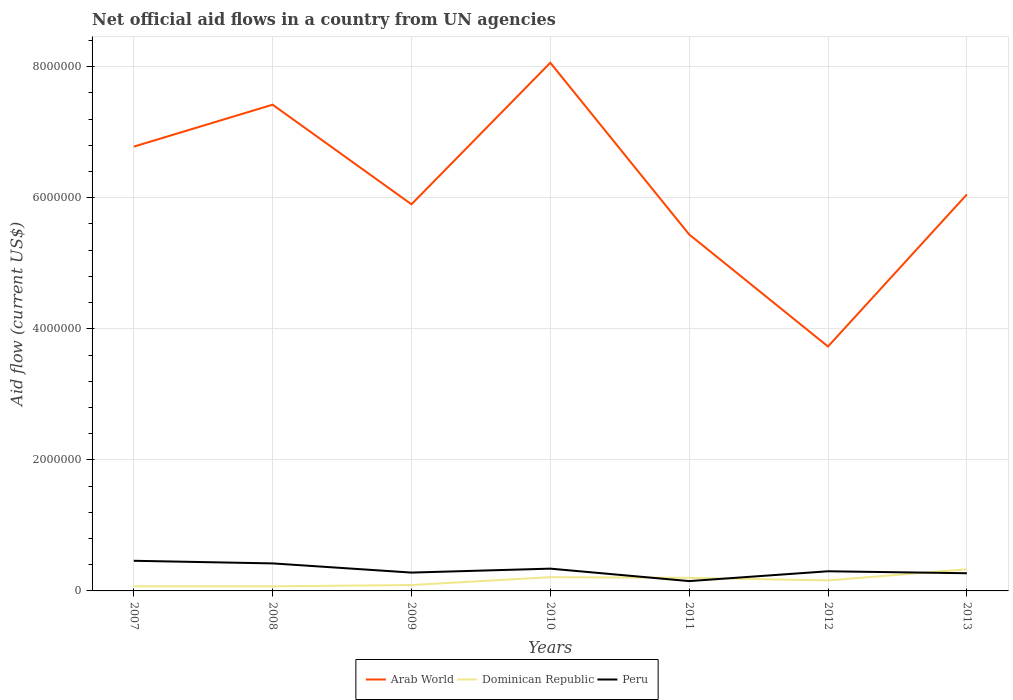Is the number of lines equal to the number of legend labels?
Keep it short and to the point. Yes. Across all years, what is the maximum net official aid flow in Dominican Republic?
Make the answer very short. 7.00e+04. In which year was the net official aid flow in Arab World maximum?
Your answer should be very brief. 2012. What is the total net official aid flow in Arab World in the graph?
Offer a terse response. -2.32e+06. What is the difference between the highest and the second highest net official aid flow in Dominican Republic?
Ensure brevity in your answer.  2.60e+05. Is the net official aid flow in Dominican Republic strictly greater than the net official aid flow in Arab World over the years?
Give a very brief answer. Yes. How many years are there in the graph?
Ensure brevity in your answer.  7. Are the values on the major ticks of Y-axis written in scientific E-notation?
Provide a short and direct response. No. Does the graph contain any zero values?
Give a very brief answer. No. Where does the legend appear in the graph?
Your answer should be compact. Bottom center. How many legend labels are there?
Your response must be concise. 3. What is the title of the graph?
Provide a succinct answer. Net official aid flows in a country from UN agencies. What is the Aid flow (current US$) in Arab World in 2007?
Your answer should be very brief. 6.78e+06. What is the Aid flow (current US$) of Peru in 2007?
Your response must be concise. 4.60e+05. What is the Aid flow (current US$) in Arab World in 2008?
Your answer should be very brief. 7.42e+06. What is the Aid flow (current US$) of Dominican Republic in 2008?
Your answer should be very brief. 7.00e+04. What is the Aid flow (current US$) of Peru in 2008?
Make the answer very short. 4.20e+05. What is the Aid flow (current US$) in Arab World in 2009?
Your answer should be compact. 5.90e+06. What is the Aid flow (current US$) of Peru in 2009?
Your answer should be very brief. 2.80e+05. What is the Aid flow (current US$) in Arab World in 2010?
Your response must be concise. 8.06e+06. What is the Aid flow (current US$) of Dominican Republic in 2010?
Provide a succinct answer. 2.10e+05. What is the Aid flow (current US$) of Peru in 2010?
Provide a succinct answer. 3.40e+05. What is the Aid flow (current US$) of Arab World in 2011?
Keep it short and to the point. 5.44e+06. What is the Aid flow (current US$) of Arab World in 2012?
Provide a short and direct response. 3.73e+06. What is the Aid flow (current US$) in Dominican Republic in 2012?
Your answer should be very brief. 1.60e+05. What is the Aid flow (current US$) of Arab World in 2013?
Your response must be concise. 6.05e+06. What is the Aid flow (current US$) of Dominican Republic in 2013?
Offer a terse response. 3.30e+05. What is the Aid flow (current US$) in Peru in 2013?
Make the answer very short. 2.70e+05. Across all years, what is the maximum Aid flow (current US$) of Arab World?
Offer a terse response. 8.06e+06. Across all years, what is the minimum Aid flow (current US$) of Arab World?
Your answer should be very brief. 3.73e+06. Across all years, what is the minimum Aid flow (current US$) of Dominican Republic?
Offer a terse response. 7.00e+04. What is the total Aid flow (current US$) of Arab World in the graph?
Your answer should be compact. 4.34e+07. What is the total Aid flow (current US$) in Dominican Republic in the graph?
Provide a succinct answer. 1.13e+06. What is the total Aid flow (current US$) of Peru in the graph?
Provide a short and direct response. 2.22e+06. What is the difference between the Aid flow (current US$) of Arab World in 2007 and that in 2008?
Provide a short and direct response. -6.40e+05. What is the difference between the Aid flow (current US$) in Dominican Republic in 2007 and that in 2008?
Your answer should be compact. 0. What is the difference between the Aid flow (current US$) of Peru in 2007 and that in 2008?
Your answer should be compact. 4.00e+04. What is the difference between the Aid flow (current US$) of Arab World in 2007 and that in 2009?
Offer a very short reply. 8.80e+05. What is the difference between the Aid flow (current US$) of Dominican Republic in 2007 and that in 2009?
Offer a terse response. -2.00e+04. What is the difference between the Aid flow (current US$) of Peru in 2007 and that in 2009?
Keep it short and to the point. 1.80e+05. What is the difference between the Aid flow (current US$) of Arab World in 2007 and that in 2010?
Ensure brevity in your answer.  -1.28e+06. What is the difference between the Aid flow (current US$) in Arab World in 2007 and that in 2011?
Make the answer very short. 1.34e+06. What is the difference between the Aid flow (current US$) in Peru in 2007 and that in 2011?
Your response must be concise. 3.10e+05. What is the difference between the Aid flow (current US$) of Arab World in 2007 and that in 2012?
Offer a terse response. 3.05e+06. What is the difference between the Aid flow (current US$) of Dominican Republic in 2007 and that in 2012?
Your answer should be compact. -9.00e+04. What is the difference between the Aid flow (current US$) of Arab World in 2007 and that in 2013?
Provide a succinct answer. 7.30e+05. What is the difference between the Aid flow (current US$) in Dominican Republic in 2007 and that in 2013?
Your response must be concise. -2.60e+05. What is the difference between the Aid flow (current US$) of Peru in 2007 and that in 2013?
Offer a very short reply. 1.90e+05. What is the difference between the Aid flow (current US$) of Arab World in 2008 and that in 2009?
Make the answer very short. 1.52e+06. What is the difference between the Aid flow (current US$) in Peru in 2008 and that in 2009?
Provide a succinct answer. 1.40e+05. What is the difference between the Aid flow (current US$) of Arab World in 2008 and that in 2010?
Provide a succinct answer. -6.40e+05. What is the difference between the Aid flow (current US$) of Dominican Republic in 2008 and that in 2010?
Your answer should be very brief. -1.40e+05. What is the difference between the Aid flow (current US$) of Peru in 2008 and that in 2010?
Provide a short and direct response. 8.00e+04. What is the difference between the Aid flow (current US$) in Arab World in 2008 and that in 2011?
Your response must be concise. 1.98e+06. What is the difference between the Aid flow (current US$) in Dominican Republic in 2008 and that in 2011?
Ensure brevity in your answer.  -1.30e+05. What is the difference between the Aid flow (current US$) in Arab World in 2008 and that in 2012?
Ensure brevity in your answer.  3.69e+06. What is the difference between the Aid flow (current US$) of Arab World in 2008 and that in 2013?
Your response must be concise. 1.37e+06. What is the difference between the Aid flow (current US$) in Peru in 2008 and that in 2013?
Your answer should be compact. 1.50e+05. What is the difference between the Aid flow (current US$) of Arab World in 2009 and that in 2010?
Offer a very short reply. -2.16e+06. What is the difference between the Aid flow (current US$) of Dominican Republic in 2009 and that in 2010?
Keep it short and to the point. -1.20e+05. What is the difference between the Aid flow (current US$) of Arab World in 2009 and that in 2012?
Your answer should be very brief. 2.17e+06. What is the difference between the Aid flow (current US$) in Dominican Republic in 2009 and that in 2013?
Give a very brief answer. -2.40e+05. What is the difference between the Aid flow (current US$) in Arab World in 2010 and that in 2011?
Offer a terse response. 2.62e+06. What is the difference between the Aid flow (current US$) in Arab World in 2010 and that in 2012?
Give a very brief answer. 4.33e+06. What is the difference between the Aid flow (current US$) in Dominican Republic in 2010 and that in 2012?
Your response must be concise. 5.00e+04. What is the difference between the Aid flow (current US$) of Arab World in 2010 and that in 2013?
Keep it short and to the point. 2.01e+06. What is the difference between the Aid flow (current US$) in Peru in 2010 and that in 2013?
Make the answer very short. 7.00e+04. What is the difference between the Aid flow (current US$) in Arab World in 2011 and that in 2012?
Offer a terse response. 1.71e+06. What is the difference between the Aid flow (current US$) of Dominican Republic in 2011 and that in 2012?
Make the answer very short. 4.00e+04. What is the difference between the Aid flow (current US$) in Peru in 2011 and that in 2012?
Provide a succinct answer. -1.50e+05. What is the difference between the Aid flow (current US$) in Arab World in 2011 and that in 2013?
Provide a short and direct response. -6.10e+05. What is the difference between the Aid flow (current US$) in Peru in 2011 and that in 2013?
Give a very brief answer. -1.20e+05. What is the difference between the Aid flow (current US$) in Arab World in 2012 and that in 2013?
Your answer should be very brief. -2.32e+06. What is the difference between the Aid flow (current US$) in Arab World in 2007 and the Aid flow (current US$) in Dominican Republic in 2008?
Your response must be concise. 6.71e+06. What is the difference between the Aid flow (current US$) of Arab World in 2007 and the Aid flow (current US$) of Peru in 2008?
Provide a succinct answer. 6.36e+06. What is the difference between the Aid flow (current US$) of Dominican Republic in 2007 and the Aid flow (current US$) of Peru in 2008?
Offer a terse response. -3.50e+05. What is the difference between the Aid flow (current US$) in Arab World in 2007 and the Aid flow (current US$) in Dominican Republic in 2009?
Offer a terse response. 6.69e+06. What is the difference between the Aid flow (current US$) of Arab World in 2007 and the Aid flow (current US$) of Peru in 2009?
Provide a succinct answer. 6.50e+06. What is the difference between the Aid flow (current US$) in Arab World in 2007 and the Aid flow (current US$) in Dominican Republic in 2010?
Give a very brief answer. 6.57e+06. What is the difference between the Aid flow (current US$) of Arab World in 2007 and the Aid flow (current US$) of Peru in 2010?
Provide a succinct answer. 6.44e+06. What is the difference between the Aid flow (current US$) of Arab World in 2007 and the Aid flow (current US$) of Dominican Republic in 2011?
Your answer should be compact. 6.58e+06. What is the difference between the Aid flow (current US$) of Arab World in 2007 and the Aid flow (current US$) of Peru in 2011?
Your answer should be very brief. 6.63e+06. What is the difference between the Aid flow (current US$) in Dominican Republic in 2007 and the Aid flow (current US$) in Peru in 2011?
Ensure brevity in your answer.  -8.00e+04. What is the difference between the Aid flow (current US$) in Arab World in 2007 and the Aid flow (current US$) in Dominican Republic in 2012?
Provide a short and direct response. 6.62e+06. What is the difference between the Aid flow (current US$) of Arab World in 2007 and the Aid flow (current US$) of Peru in 2012?
Keep it short and to the point. 6.48e+06. What is the difference between the Aid flow (current US$) of Dominican Republic in 2007 and the Aid flow (current US$) of Peru in 2012?
Ensure brevity in your answer.  -2.30e+05. What is the difference between the Aid flow (current US$) in Arab World in 2007 and the Aid flow (current US$) in Dominican Republic in 2013?
Your response must be concise. 6.45e+06. What is the difference between the Aid flow (current US$) in Arab World in 2007 and the Aid flow (current US$) in Peru in 2013?
Your response must be concise. 6.51e+06. What is the difference between the Aid flow (current US$) in Arab World in 2008 and the Aid flow (current US$) in Dominican Republic in 2009?
Keep it short and to the point. 7.33e+06. What is the difference between the Aid flow (current US$) of Arab World in 2008 and the Aid flow (current US$) of Peru in 2009?
Give a very brief answer. 7.14e+06. What is the difference between the Aid flow (current US$) in Arab World in 2008 and the Aid flow (current US$) in Dominican Republic in 2010?
Ensure brevity in your answer.  7.21e+06. What is the difference between the Aid flow (current US$) of Arab World in 2008 and the Aid flow (current US$) of Peru in 2010?
Your answer should be very brief. 7.08e+06. What is the difference between the Aid flow (current US$) of Arab World in 2008 and the Aid flow (current US$) of Dominican Republic in 2011?
Ensure brevity in your answer.  7.22e+06. What is the difference between the Aid flow (current US$) of Arab World in 2008 and the Aid flow (current US$) of Peru in 2011?
Offer a terse response. 7.27e+06. What is the difference between the Aid flow (current US$) of Dominican Republic in 2008 and the Aid flow (current US$) of Peru in 2011?
Your answer should be compact. -8.00e+04. What is the difference between the Aid flow (current US$) of Arab World in 2008 and the Aid flow (current US$) of Dominican Republic in 2012?
Provide a succinct answer. 7.26e+06. What is the difference between the Aid flow (current US$) of Arab World in 2008 and the Aid flow (current US$) of Peru in 2012?
Provide a short and direct response. 7.12e+06. What is the difference between the Aid flow (current US$) of Arab World in 2008 and the Aid flow (current US$) of Dominican Republic in 2013?
Provide a succinct answer. 7.09e+06. What is the difference between the Aid flow (current US$) of Arab World in 2008 and the Aid flow (current US$) of Peru in 2013?
Offer a very short reply. 7.15e+06. What is the difference between the Aid flow (current US$) in Dominican Republic in 2008 and the Aid flow (current US$) in Peru in 2013?
Provide a succinct answer. -2.00e+05. What is the difference between the Aid flow (current US$) in Arab World in 2009 and the Aid flow (current US$) in Dominican Republic in 2010?
Offer a terse response. 5.69e+06. What is the difference between the Aid flow (current US$) in Arab World in 2009 and the Aid flow (current US$) in Peru in 2010?
Provide a short and direct response. 5.56e+06. What is the difference between the Aid flow (current US$) in Arab World in 2009 and the Aid flow (current US$) in Dominican Republic in 2011?
Offer a terse response. 5.70e+06. What is the difference between the Aid flow (current US$) of Arab World in 2009 and the Aid flow (current US$) of Peru in 2011?
Offer a terse response. 5.75e+06. What is the difference between the Aid flow (current US$) of Arab World in 2009 and the Aid flow (current US$) of Dominican Republic in 2012?
Your answer should be very brief. 5.74e+06. What is the difference between the Aid flow (current US$) of Arab World in 2009 and the Aid flow (current US$) of Peru in 2012?
Provide a short and direct response. 5.60e+06. What is the difference between the Aid flow (current US$) in Arab World in 2009 and the Aid flow (current US$) in Dominican Republic in 2013?
Offer a very short reply. 5.57e+06. What is the difference between the Aid flow (current US$) in Arab World in 2009 and the Aid flow (current US$) in Peru in 2013?
Give a very brief answer. 5.63e+06. What is the difference between the Aid flow (current US$) of Dominican Republic in 2009 and the Aid flow (current US$) of Peru in 2013?
Your answer should be compact. -1.80e+05. What is the difference between the Aid flow (current US$) of Arab World in 2010 and the Aid flow (current US$) of Dominican Republic in 2011?
Give a very brief answer. 7.86e+06. What is the difference between the Aid flow (current US$) in Arab World in 2010 and the Aid flow (current US$) in Peru in 2011?
Your answer should be very brief. 7.91e+06. What is the difference between the Aid flow (current US$) in Arab World in 2010 and the Aid flow (current US$) in Dominican Republic in 2012?
Your answer should be compact. 7.90e+06. What is the difference between the Aid flow (current US$) in Arab World in 2010 and the Aid flow (current US$) in Peru in 2012?
Provide a short and direct response. 7.76e+06. What is the difference between the Aid flow (current US$) in Arab World in 2010 and the Aid flow (current US$) in Dominican Republic in 2013?
Your answer should be very brief. 7.73e+06. What is the difference between the Aid flow (current US$) of Arab World in 2010 and the Aid flow (current US$) of Peru in 2013?
Ensure brevity in your answer.  7.79e+06. What is the difference between the Aid flow (current US$) of Arab World in 2011 and the Aid flow (current US$) of Dominican Republic in 2012?
Ensure brevity in your answer.  5.28e+06. What is the difference between the Aid flow (current US$) of Arab World in 2011 and the Aid flow (current US$) of Peru in 2012?
Your response must be concise. 5.14e+06. What is the difference between the Aid flow (current US$) in Dominican Republic in 2011 and the Aid flow (current US$) in Peru in 2012?
Provide a succinct answer. -1.00e+05. What is the difference between the Aid flow (current US$) in Arab World in 2011 and the Aid flow (current US$) in Dominican Republic in 2013?
Your answer should be compact. 5.11e+06. What is the difference between the Aid flow (current US$) in Arab World in 2011 and the Aid flow (current US$) in Peru in 2013?
Your answer should be very brief. 5.17e+06. What is the difference between the Aid flow (current US$) of Dominican Republic in 2011 and the Aid flow (current US$) of Peru in 2013?
Keep it short and to the point. -7.00e+04. What is the difference between the Aid flow (current US$) of Arab World in 2012 and the Aid flow (current US$) of Dominican Republic in 2013?
Offer a very short reply. 3.40e+06. What is the difference between the Aid flow (current US$) in Arab World in 2012 and the Aid flow (current US$) in Peru in 2013?
Offer a terse response. 3.46e+06. What is the average Aid flow (current US$) of Arab World per year?
Offer a very short reply. 6.20e+06. What is the average Aid flow (current US$) of Dominican Republic per year?
Make the answer very short. 1.61e+05. What is the average Aid flow (current US$) of Peru per year?
Your answer should be very brief. 3.17e+05. In the year 2007, what is the difference between the Aid flow (current US$) of Arab World and Aid flow (current US$) of Dominican Republic?
Keep it short and to the point. 6.71e+06. In the year 2007, what is the difference between the Aid flow (current US$) of Arab World and Aid flow (current US$) of Peru?
Your response must be concise. 6.32e+06. In the year 2007, what is the difference between the Aid flow (current US$) in Dominican Republic and Aid flow (current US$) in Peru?
Your answer should be very brief. -3.90e+05. In the year 2008, what is the difference between the Aid flow (current US$) in Arab World and Aid flow (current US$) in Dominican Republic?
Give a very brief answer. 7.35e+06. In the year 2008, what is the difference between the Aid flow (current US$) of Dominican Republic and Aid flow (current US$) of Peru?
Keep it short and to the point. -3.50e+05. In the year 2009, what is the difference between the Aid flow (current US$) in Arab World and Aid flow (current US$) in Dominican Republic?
Offer a very short reply. 5.81e+06. In the year 2009, what is the difference between the Aid flow (current US$) in Arab World and Aid flow (current US$) in Peru?
Offer a very short reply. 5.62e+06. In the year 2010, what is the difference between the Aid flow (current US$) in Arab World and Aid flow (current US$) in Dominican Republic?
Provide a short and direct response. 7.85e+06. In the year 2010, what is the difference between the Aid flow (current US$) of Arab World and Aid flow (current US$) of Peru?
Give a very brief answer. 7.72e+06. In the year 2010, what is the difference between the Aid flow (current US$) in Dominican Republic and Aid flow (current US$) in Peru?
Provide a short and direct response. -1.30e+05. In the year 2011, what is the difference between the Aid flow (current US$) in Arab World and Aid flow (current US$) in Dominican Republic?
Your answer should be compact. 5.24e+06. In the year 2011, what is the difference between the Aid flow (current US$) of Arab World and Aid flow (current US$) of Peru?
Your answer should be very brief. 5.29e+06. In the year 2012, what is the difference between the Aid flow (current US$) in Arab World and Aid flow (current US$) in Dominican Republic?
Ensure brevity in your answer.  3.57e+06. In the year 2012, what is the difference between the Aid flow (current US$) of Arab World and Aid flow (current US$) of Peru?
Make the answer very short. 3.43e+06. In the year 2012, what is the difference between the Aid flow (current US$) of Dominican Republic and Aid flow (current US$) of Peru?
Make the answer very short. -1.40e+05. In the year 2013, what is the difference between the Aid flow (current US$) of Arab World and Aid flow (current US$) of Dominican Republic?
Give a very brief answer. 5.72e+06. In the year 2013, what is the difference between the Aid flow (current US$) of Arab World and Aid flow (current US$) of Peru?
Make the answer very short. 5.78e+06. In the year 2013, what is the difference between the Aid flow (current US$) of Dominican Republic and Aid flow (current US$) of Peru?
Offer a terse response. 6.00e+04. What is the ratio of the Aid flow (current US$) in Arab World in 2007 to that in 2008?
Offer a very short reply. 0.91. What is the ratio of the Aid flow (current US$) of Dominican Republic in 2007 to that in 2008?
Give a very brief answer. 1. What is the ratio of the Aid flow (current US$) of Peru in 2007 to that in 2008?
Offer a very short reply. 1.1. What is the ratio of the Aid flow (current US$) in Arab World in 2007 to that in 2009?
Make the answer very short. 1.15. What is the ratio of the Aid flow (current US$) of Dominican Republic in 2007 to that in 2009?
Your answer should be very brief. 0.78. What is the ratio of the Aid flow (current US$) in Peru in 2007 to that in 2009?
Give a very brief answer. 1.64. What is the ratio of the Aid flow (current US$) in Arab World in 2007 to that in 2010?
Offer a very short reply. 0.84. What is the ratio of the Aid flow (current US$) in Dominican Republic in 2007 to that in 2010?
Offer a very short reply. 0.33. What is the ratio of the Aid flow (current US$) in Peru in 2007 to that in 2010?
Provide a succinct answer. 1.35. What is the ratio of the Aid flow (current US$) in Arab World in 2007 to that in 2011?
Your answer should be compact. 1.25. What is the ratio of the Aid flow (current US$) in Dominican Republic in 2007 to that in 2011?
Your answer should be compact. 0.35. What is the ratio of the Aid flow (current US$) of Peru in 2007 to that in 2011?
Keep it short and to the point. 3.07. What is the ratio of the Aid flow (current US$) in Arab World in 2007 to that in 2012?
Provide a succinct answer. 1.82. What is the ratio of the Aid flow (current US$) of Dominican Republic in 2007 to that in 2012?
Provide a succinct answer. 0.44. What is the ratio of the Aid flow (current US$) in Peru in 2007 to that in 2012?
Offer a terse response. 1.53. What is the ratio of the Aid flow (current US$) in Arab World in 2007 to that in 2013?
Make the answer very short. 1.12. What is the ratio of the Aid flow (current US$) in Dominican Republic in 2007 to that in 2013?
Provide a succinct answer. 0.21. What is the ratio of the Aid flow (current US$) of Peru in 2007 to that in 2013?
Offer a terse response. 1.7. What is the ratio of the Aid flow (current US$) of Arab World in 2008 to that in 2009?
Your response must be concise. 1.26. What is the ratio of the Aid flow (current US$) of Peru in 2008 to that in 2009?
Give a very brief answer. 1.5. What is the ratio of the Aid flow (current US$) in Arab World in 2008 to that in 2010?
Make the answer very short. 0.92. What is the ratio of the Aid flow (current US$) of Peru in 2008 to that in 2010?
Offer a terse response. 1.24. What is the ratio of the Aid flow (current US$) in Arab World in 2008 to that in 2011?
Give a very brief answer. 1.36. What is the ratio of the Aid flow (current US$) of Peru in 2008 to that in 2011?
Offer a terse response. 2.8. What is the ratio of the Aid flow (current US$) of Arab World in 2008 to that in 2012?
Offer a very short reply. 1.99. What is the ratio of the Aid flow (current US$) in Dominican Republic in 2008 to that in 2012?
Your response must be concise. 0.44. What is the ratio of the Aid flow (current US$) of Peru in 2008 to that in 2012?
Keep it short and to the point. 1.4. What is the ratio of the Aid flow (current US$) in Arab World in 2008 to that in 2013?
Keep it short and to the point. 1.23. What is the ratio of the Aid flow (current US$) of Dominican Republic in 2008 to that in 2013?
Offer a very short reply. 0.21. What is the ratio of the Aid flow (current US$) in Peru in 2008 to that in 2013?
Ensure brevity in your answer.  1.56. What is the ratio of the Aid flow (current US$) in Arab World in 2009 to that in 2010?
Offer a terse response. 0.73. What is the ratio of the Aid flow (current US$) of Dominican Republic in 2009 to that in 2010?
Offer a very short reply. 0.43. What is the ratio of the Aid flow (current US$) of Peru in 2009 to that in 2010?
Ensure brevity in your answer.  0.82. What is the ratio of the Aid flow (current US$) of Arab World in 2009 to that in 2011?
Offer a very short reply. 1.08. What is the ratio of the Aid flow (current US$) in Dominican Republic in 2009 to that in 2011?
Keep it short and to the point. 0.45. What is the ratio of the Aid flow (current US$) of Peru in 2009 to that in 2011?
Your answer should be compact. 1.87. What is the ratio of the Aid flow (current US$) in Arab World in 2009 to that in 2012?
Provide a short and direct response. 1.58. What is the ratio of the Aid flow (current US$) of Dominican Republic in 2009 to that in 2012?
Provide a short and direct response. 0.56. What is the ratio of the Aid flow (current US$) in Peru in 2009 to that in 2012?
Keep it short and to the point. 0.93. What is the ratio of the Aid flow (current US$) in Arab World in 2009 to that in 2013?
Provide a succinct answer. 0.98. What is the ratio of the Aid flow (current US$) in Dominican Republic in 2009 to that in 2013?
Make the answer very short. 0.27. What is the ratio of the Aid flow (current US$) of Arab World in 2010 to that in 2011?
Offer a terse response. 1.48. What is the ratio of the Aid flow (current US$) in Peru in 2010 to that in 2011?
Provide a short and direct response. 2.27. What is the ratio of the Aid flow (current US$) of Arab World in 2010 to that in 2012?
Keep it short and to the point. 2.16. What is the ratio of the Aid flow (current US$) in Dominican Republic in 2010 to that in 2012?
Provide a succinct answer. 1.31. What is the ratio of the Aid flow (current US$) in Peru in 2010 to that in 2012?
Provide a succinct answer. 1.13. What is the ratio of the Aid flow (current US$) of Arab World in 2010 to that in 2013?
Ensure brevity in your answer.  1.33. What is the ratio of the Aid flow (current US$) in Dominican Republic in 2010 to that in 2013?
Your answer should be very brief. 0.64. What is the ratio of the Aid flow (current US$) of Peru in 2010 to that in 2013?
Give a very brief answer. 1.26. What is the ratio of the Aid flow (current US$) of Arab World in 2011 to that in 2012?
Offer a very short reply. 1.46. What is the ratio of the Aid flow (current US$) of Dominican Republic in 2011 to that in 2012?
Your answer should be compact. 1.25. What is the ratio of the Aid flow (current US$) of Peru in 2011 to that in 2012?
Provide a short and direct response. 0.5. What is the ratio of the Aid flow (current US$) in Arab World in 2011 to that in 2013?
Provide a succinct answer. 0.9. What is the ratio of the Aid flow (current US$) in Dominican Republic in 2011 to that in 2013?
Ensure brevity in your answer.  0.61. What is the ratio of the Aid flow (current US$) in Peru in 2011 to that in 2013?
Offer a very short reply. 0.56. What is the ratio of the Aid flow (current US$) of Arab World in 2012 to that in 2013?
Make the answer very short. 0.62. What is the ratio of the Aid flow (current US$) in Dominican Republic in 2012 to that in 2013?
Provide a short and direct response. 0.48. What is the ratio of the Aid flow (current US$) of Peru in 2012 to that in 2013?
Ensure brevity in your answer.  1.11. What is the difference between the highest and the second highest Aid flow (current US$) in Arab World?
Offer a very short reply. 6.40e+05. What is the difference between the highest and the second highest Aid flow (current US$) in Dominican Republic?
Your response must be concise. 1.20e+05. What is the difference between the highest and the lowest Aid flow (current US$) of Arab World?
Provide a succinct answer. 4.33e+06. 